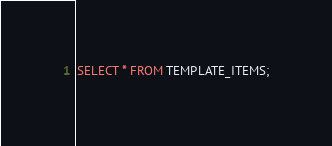Convert code to text. <code><loc_0><loc_0><loc_500><loc_500><_SQL_>SELECT * FROM TEMPLATE_ITEMS;
</code> 